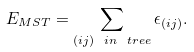Convert formula to latex. <formula><loc_0><loc_0><loc_500><loc_500>E _ { M S T } = \sum _ { ( i j ) \ i n \ t r e e } \epsilon _ { ( i j ) } .</formula> 